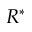<formula> <loc_0><loc_0><loc_500><loc_500>R ^ { * }</formula> 